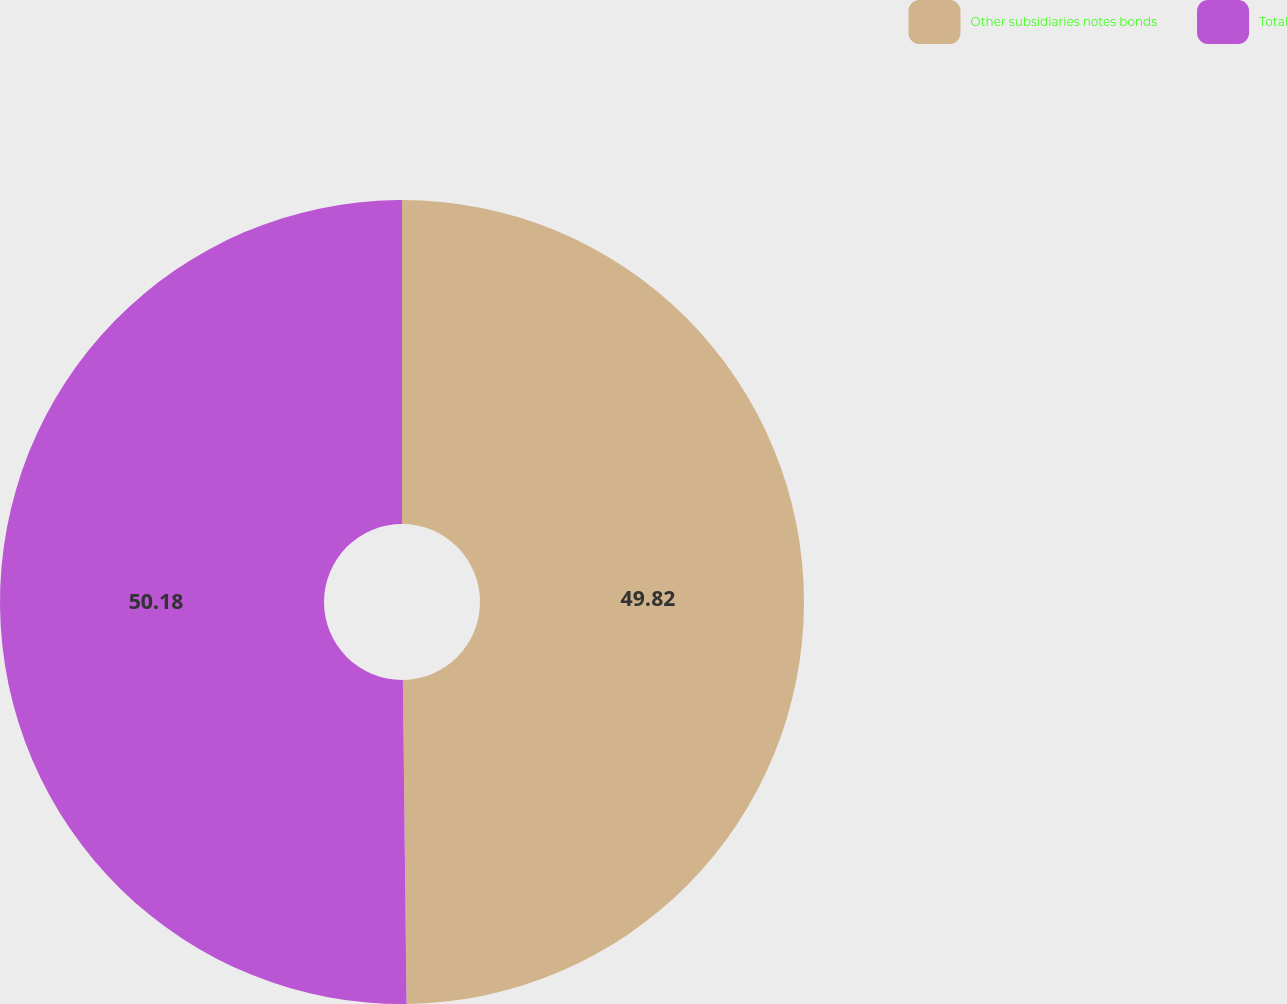Convert chart to OTSL. <chart><loc_0><loc_0><loc_500><loc_500><pie_chart><fcel>Other subsidiaries notes bonds<fcel>Total<nl><fcel>49.82%<fcel>50.18%<nl></chart> 